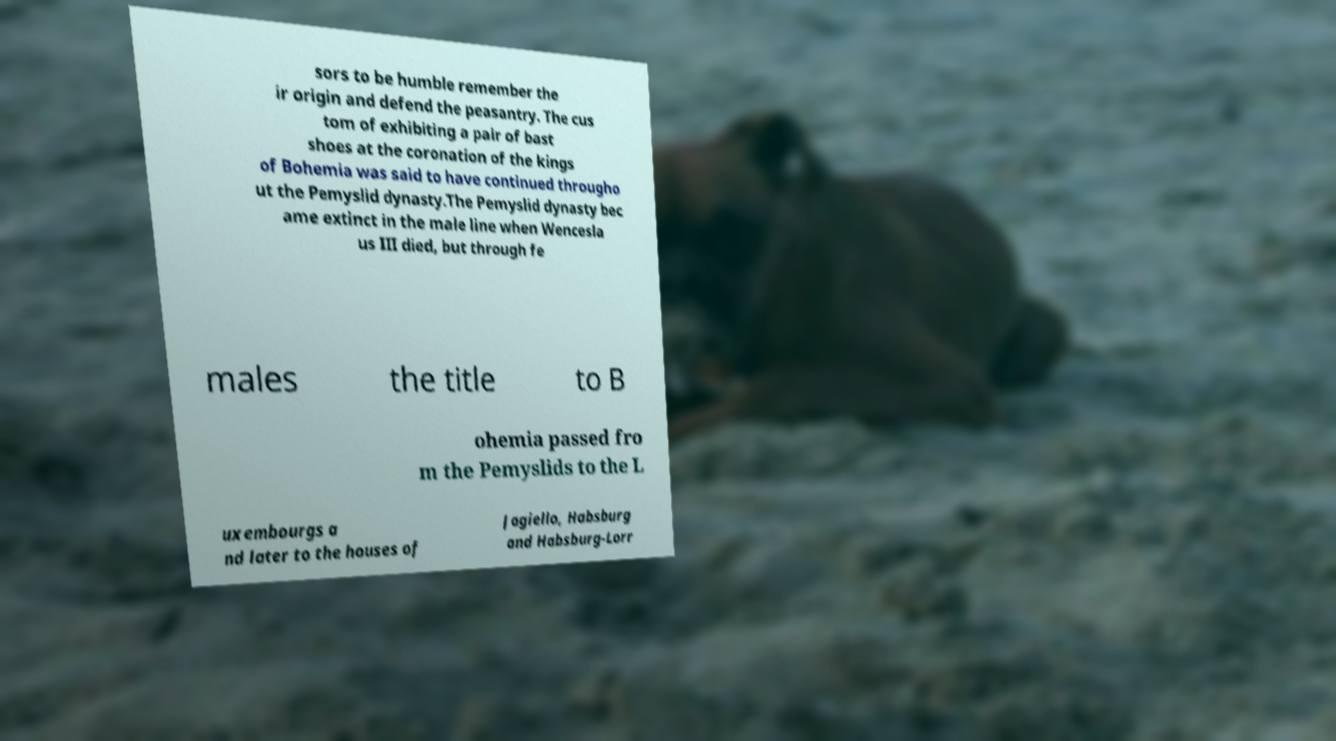I need the written content from this picture converted into text. Can you do that? sors to be humble remember the ir origin and defend the peasantry. The cus tom of exhibiting a pair of bast shoes at the coronation of the kings of Bohemia was said to have continued througho ut the Pemyslid dynasty.The Pemyslid dynasty bec ame extinct in the male line when Wencesla us III died, but through fe males the title to B ohemia passed fro m the Pemyslids to the L uxembourgs a nd later to the houses of Jagiello, Habsburg and Habsburg-Lorr 